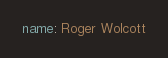Convert code to text. <code><loc_0><loc_0><loc_500><loc_500><_YAML_>name: Roger Wolcott
</code> 